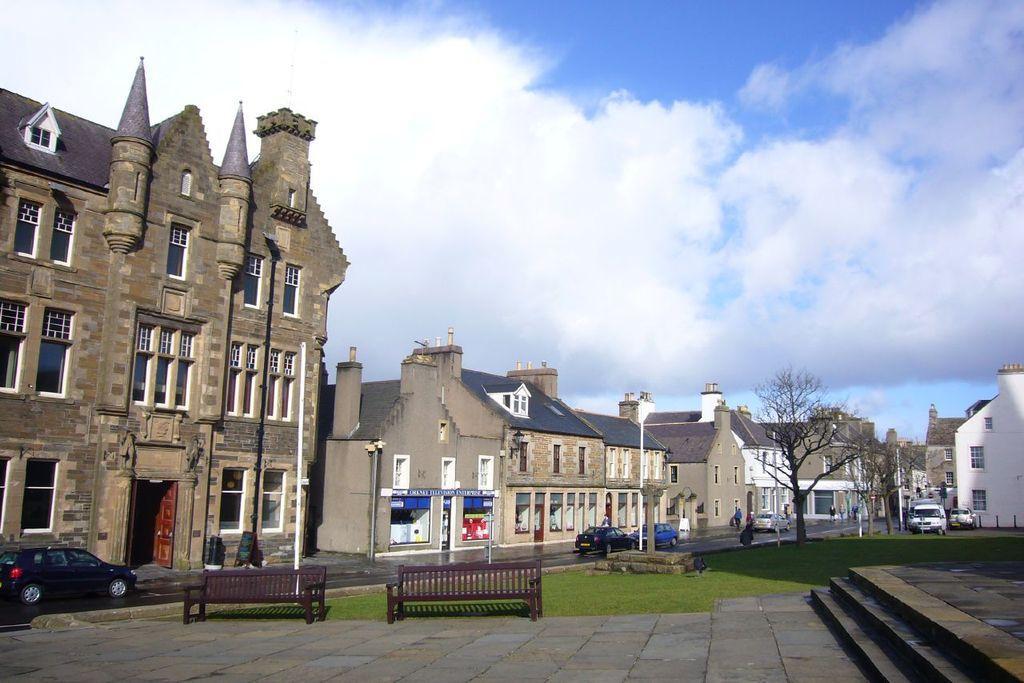Please provide a concise description of this image. In this picture there are two benches and there is greenery ground behind it and there are few steps in the right corner and there are few vehicles on the road and there are buildings in the background and the sky is cloudy. 